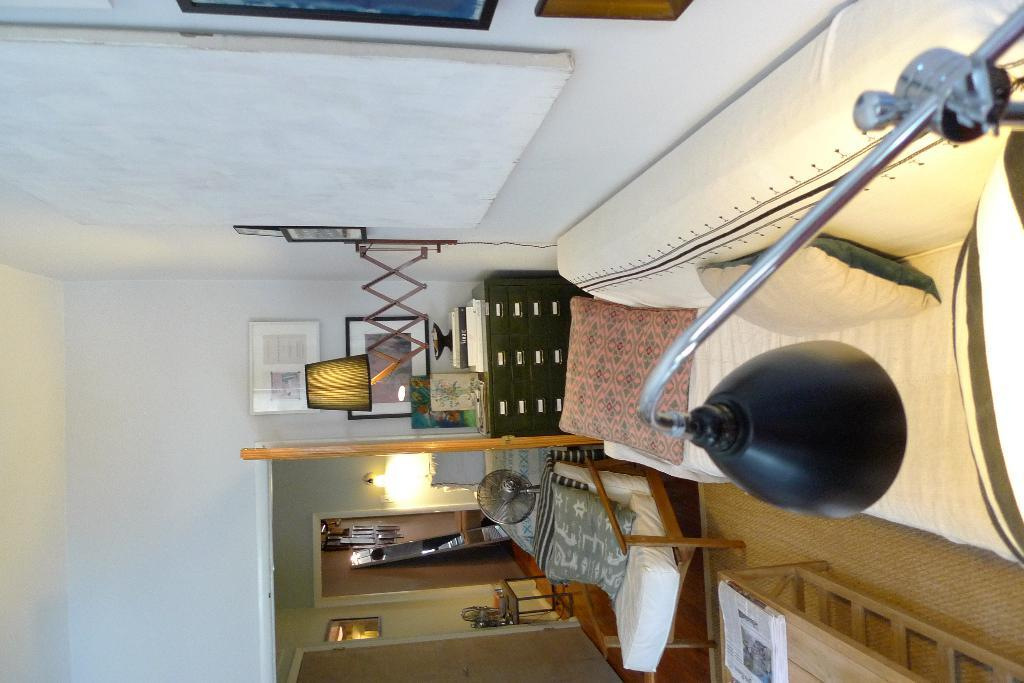What type of furniture is present in the room? There is a couch, a table, a chair, and a board in the room. What items can be found on the furniture? There are pillows on the couch and books on the table. What decorative items are in the room? There are lamps, a photo frame, and a board in the room. How many rooms are visible in the image? There is one room visible, and another room is visible at the back. What type of meal is being served in the room? There is no meal being served in the room; the image only shows furniture and decorative items. What type of joke is hanging on the wall in the room? There is no joke present in the room; the image only shows a board, which could be used for various purposes, but not for displaying jokes. 